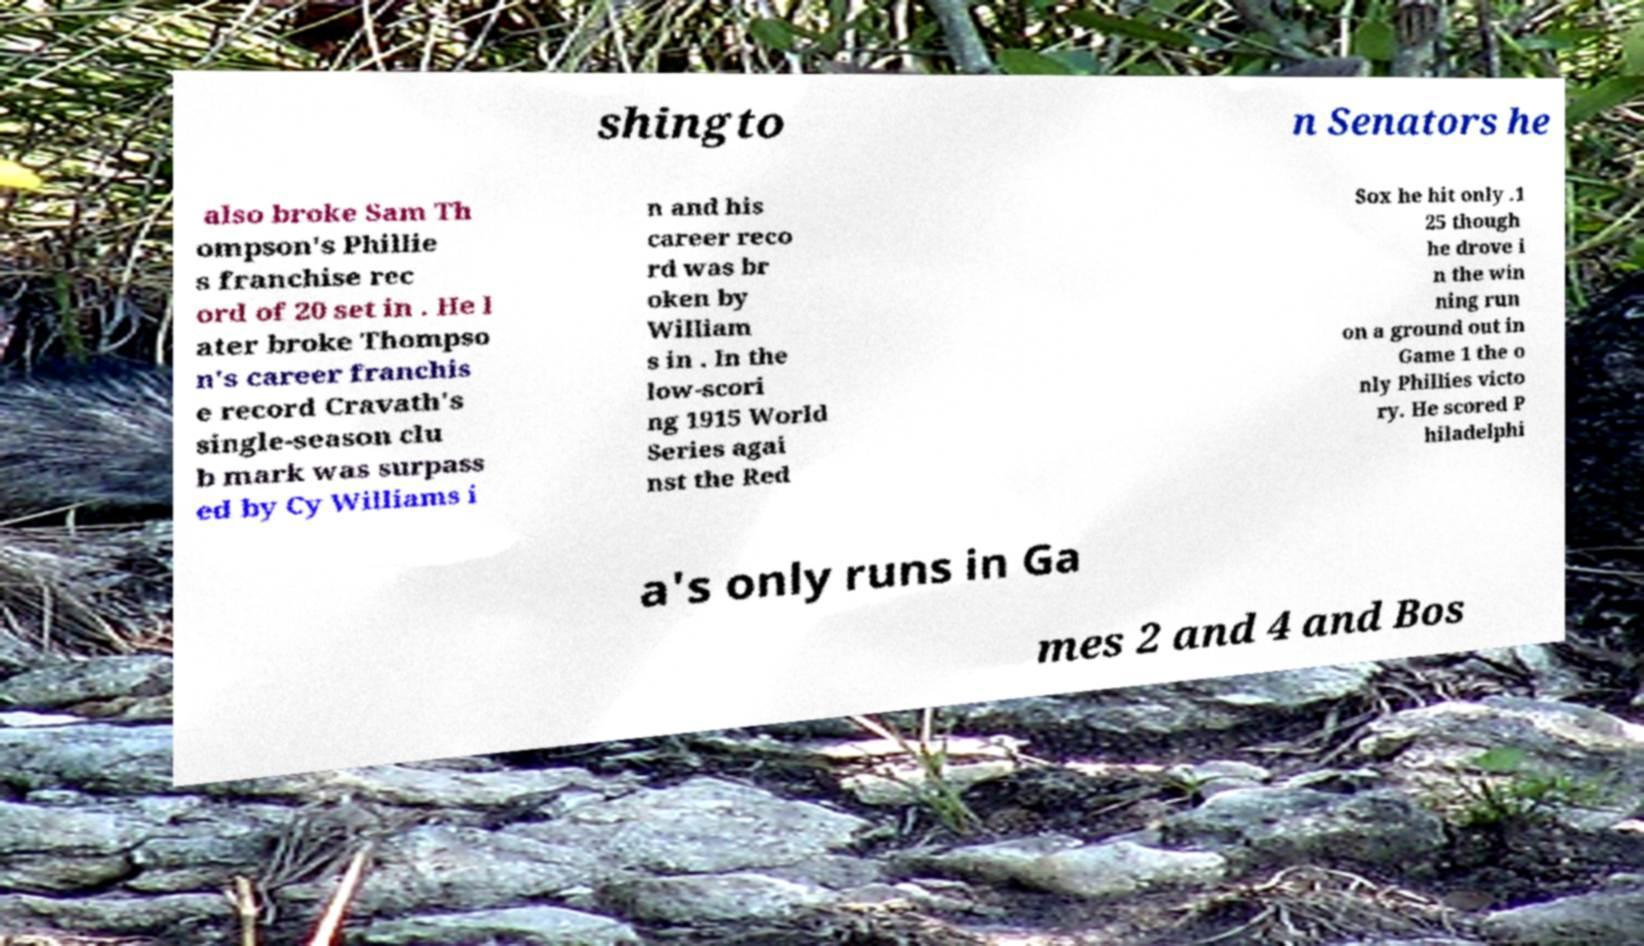Could you assist in decoding the text presented in this image and type it out clearly? shingto n Senators he also broke Sam Th ompson's Phillie s franchise rec ord of 20 set in . He l ater broke Thompso n's career franchis e record Cravath's single-season clu b mark was surpass ed by Cy Williams i n and his career reco rd was br oken by William s in . In the low-scori ng 1915 World Series agai nst the Red Sox he hit only .1 25 though he drove i n the win ning run on a ground out in Game 1 the o nly Phillies victo ry. He scored P hiladelphi a's only runs in Ga mes 2 and 4 and Bos 